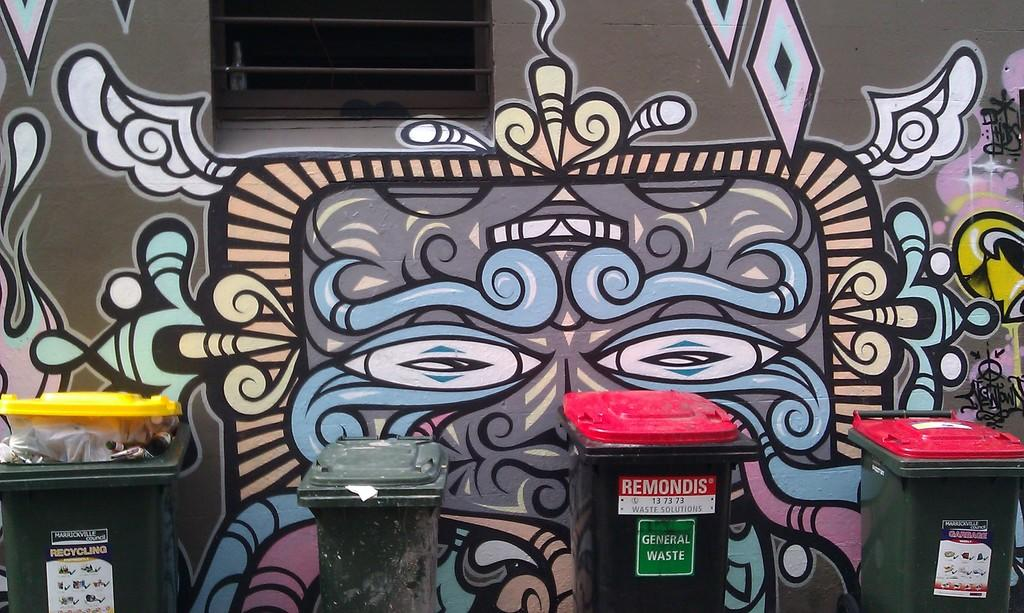<image>
Summarize the visual content of the image. Graffiti behind a garbage can which says "REMONDIS" in red. 